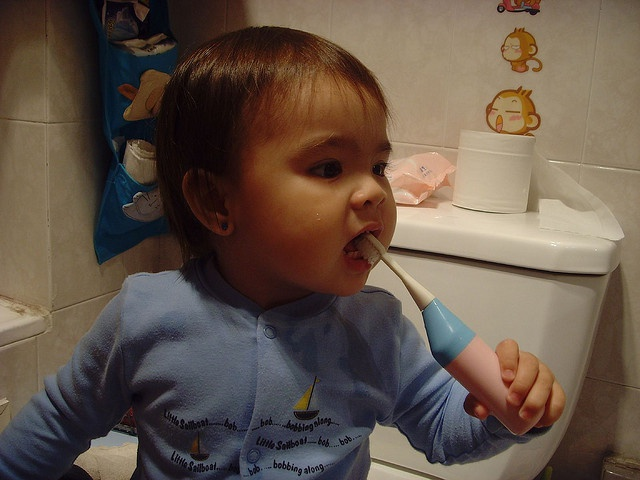Describe the objects in this image and their specific colors. I can see people in black, gray, and maroon tones, toilet in black, tan, and gray tones, and toothbrush in black, maroon, gray, and tan tones in this image. 